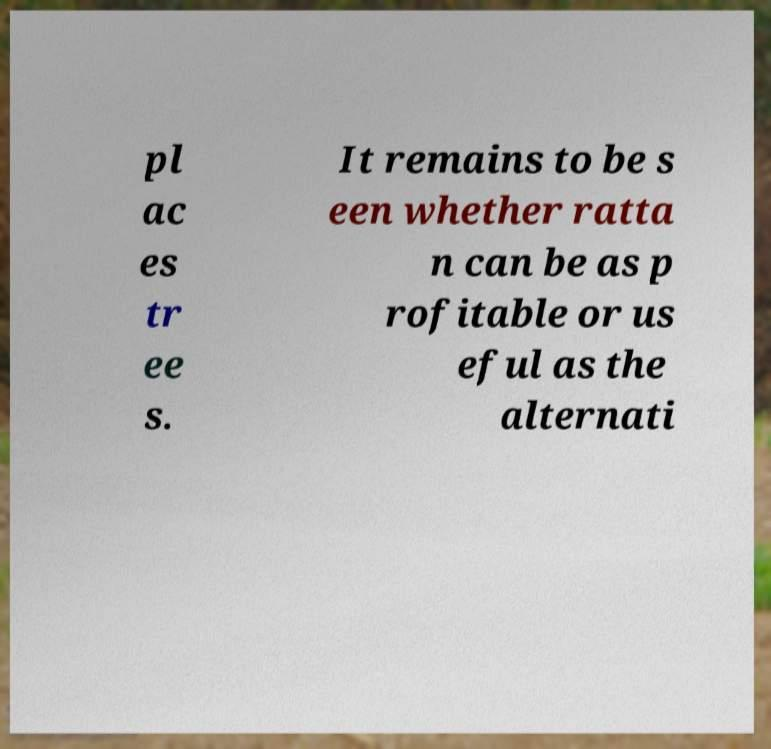There's text embedded in this image that I need extracted. Can you transcribe it verbatim? pl ac es tr ee s. It remains to be s een whether ratta n can be as p rofitable or us eful as the alternati 